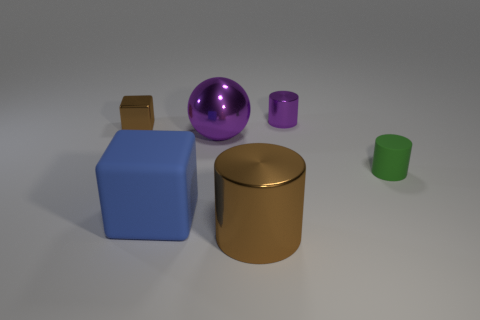What is the shape of the tiny shiny thing that is the same color as the big ball?
Your response must be concise. Cylinder. There is a purple object left of the tiny purple object; what is its material?
Keep it short and to the point. Metal. What number of objects are either tiny purple shiny cylinders or tiny cubes behind the large shiny sphere?
Your answer should be very brief. 2. The green rubber thing that is the same size as the purple cylinder is what shape?
Keep it short and to the point. Cylinder. What number of cylinders have the same color as the metallic sphere?
Keep it short and to the point. 1. Does the brown object that is on the right side of the big blue rubber block have the same material as the brown cube?
Provide a succinct answer. Yes. What is the shape of the blue object?
Your response must be concise. Cube. What number of green objects are either cylinders or large objects?
Keep it short and to the point. 1. How many other things are the same material as the large blue object?
Ensure brevity in your answer.  1. Do the rubber object in front of the green thing and the small brown object have the same shape?
Your response must be concise. Yes. 